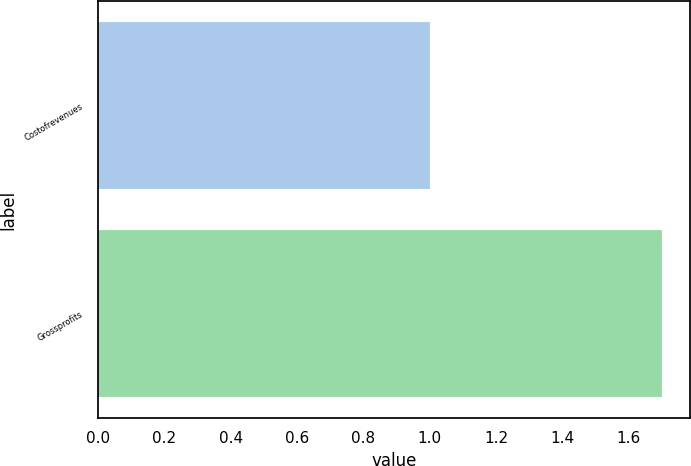Convert chart. <chart><loc_0><loc_0><loc_500><loc_500><bar_chart><fcel>Costofrevenues<fcel>Grossprofits<nl><fcel>1<fcel>1.7<nl></chart> 